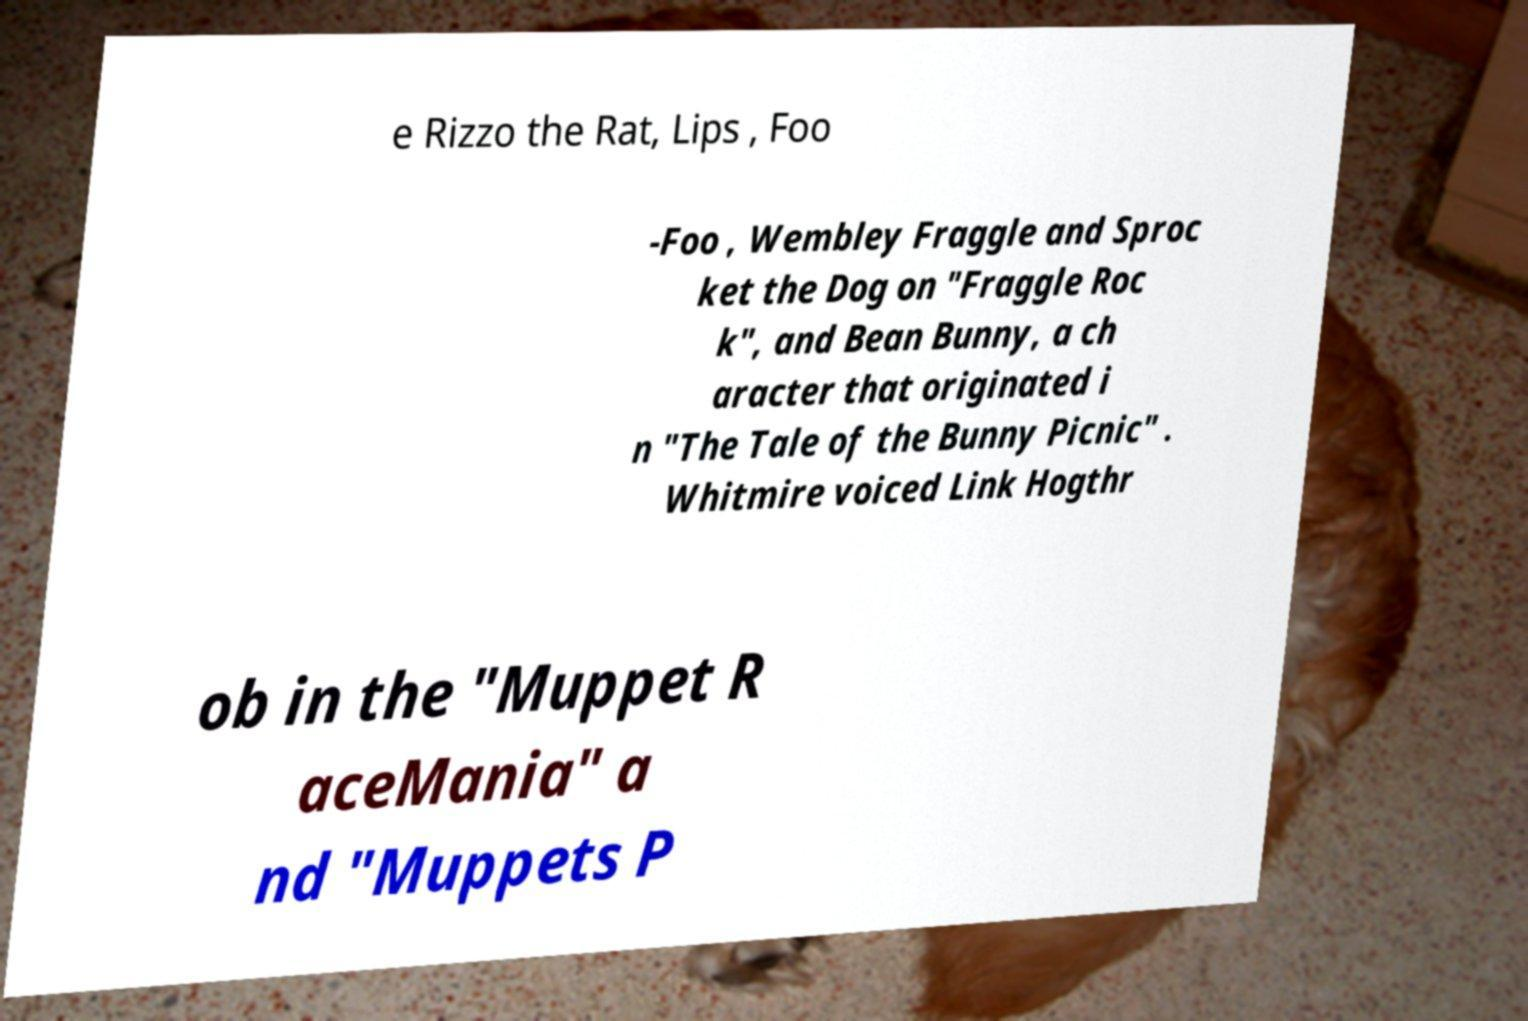There's text embedded in this image that I need extracted. Can you transcribe it verbatim? e Rizzo the Rat, Lips , Foo -Foo , Wembley Fraggle and Sproc ket the Dog on "Fraggle Roc k", and Bean Bunny, a ch aracter that originated i n "The Tale of the Bunny Picnic" . Whitmire voiced Link Hogthr ob in the "Muppet R aceMania" a nd "Muppets P 